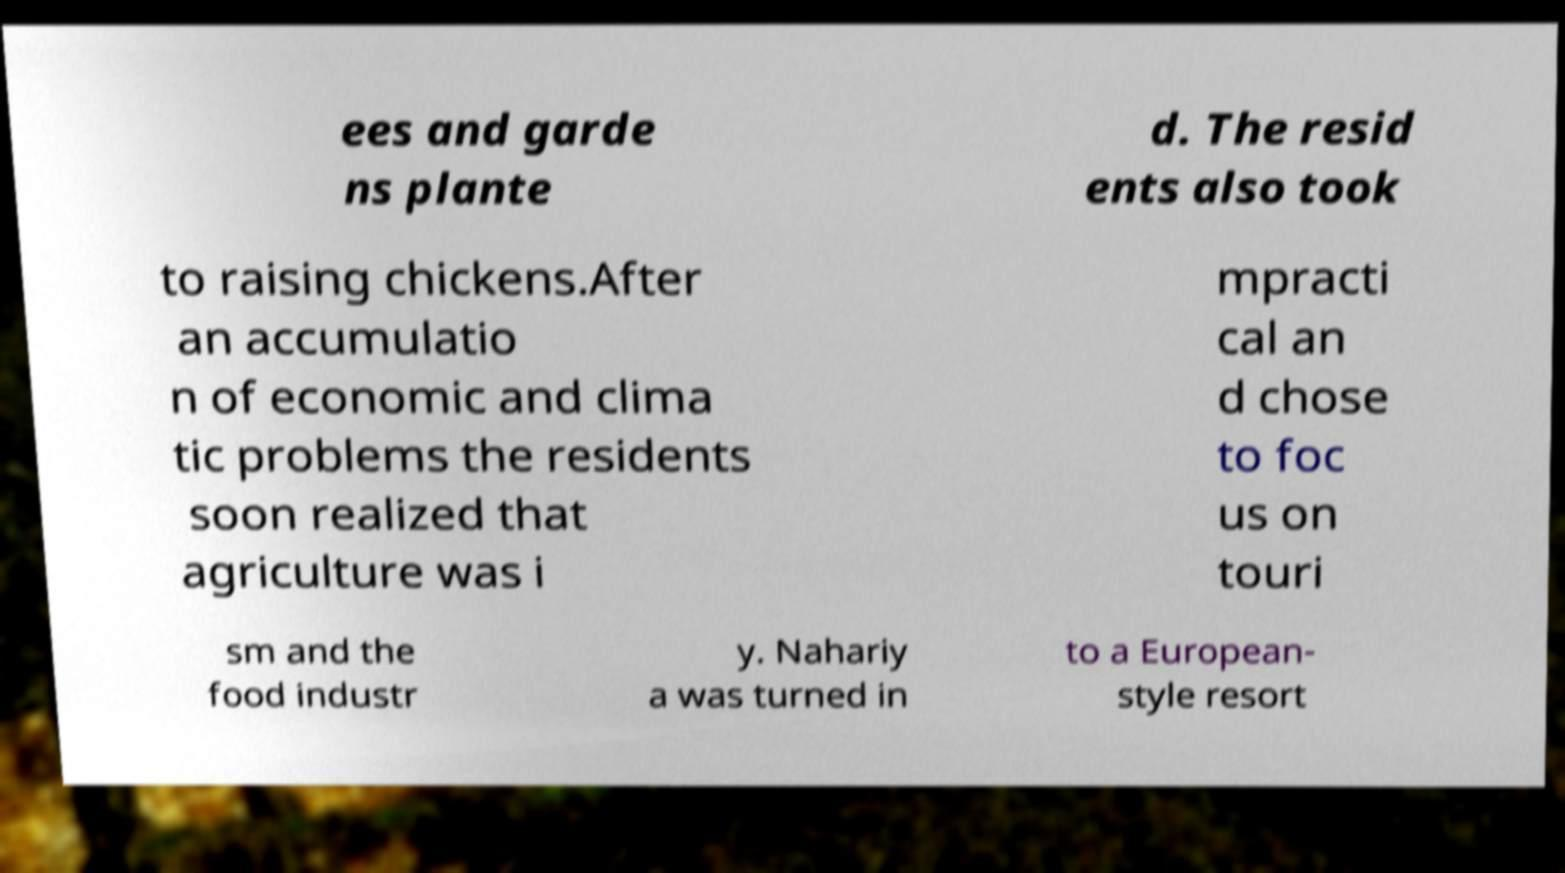Could you extract and type out the text from this image? ees and garde ns plante d. The resid ents also took to raising chickens.After an accumulatio n of economic and clima tic problems the residents soon realized that agriculture was i mpracti cal an d chose to foc us on touri sm and the food industr y. Nahariy a was turned in to a European- style resort 